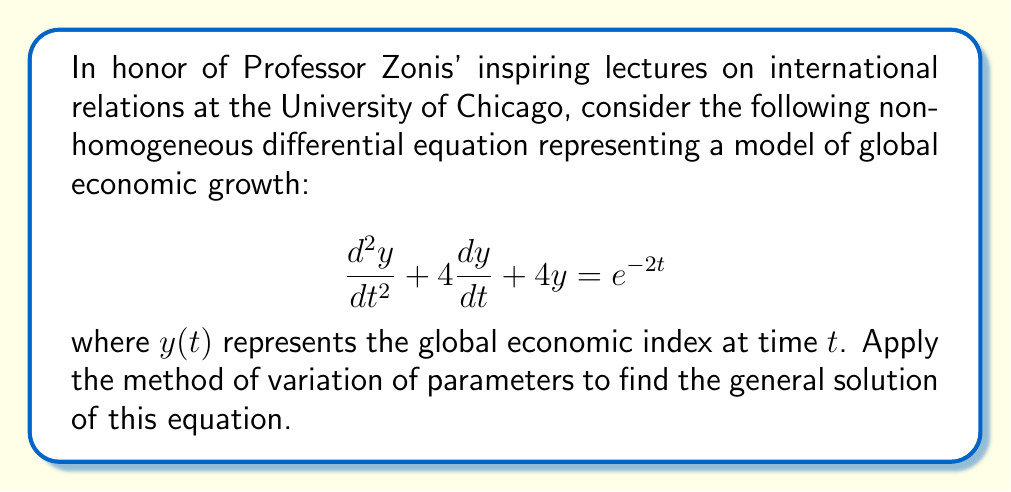Teach me how to tackle this problem. Let's solve this step-by-step using the method of variation of parameters:

1) First, we need to solve the homogeneous equation:
   $$\frac{d^2y}{dt^2} + 4\frac{dy}{dt} + 4y = 0$$

   The characteristic equation is $r^2 + 4r + 4 = 0$
   $(r + 2)^2 = 0$, so $r = -2$ (double root)

   The homogeneous solution is:
   $$y_h = c_1e^{-2t} + c_2te^{-2t}$$

2) Now, we use the method of variation of parameters. Let:
   $$y_p = u_1y_1 + u_2y_2$$
   where $y_1 = e^{-2t}$ and $y_2 = te^{-2t}$

3) We need to solve the system:
   $$\begin{cases}
   u_1'y_1 + u_2'y_2 = 0 \\
   u_1'y_1' + u_2'y_2' = e^{-2t}
   \end{cases}$$

4) Substituting the values:
   $$\begin{cases}
   u_1'e^{-2t} + u_2'te^{-2t} = 0 \\
   u_1'(-2e^{-2t}) + u_2'(e^{-2t} - 2te^{-2t}) = e^{-2t}
   \end{cases}$$

5) Solving this system:
   $$u_1' = \frac{-te^{-2t}}{W} = -\frac{t}{2}$$
   $$u_2' = \frac{e^{-2t}}{W} = \frac{1}{2}$$
   where $W = e^{-4t}$ is the Wronskian

6) Integrating:
   $$u_1 = -\frac{t^2}{4} + C_1$$
   $$u_2 = \frac{t}{2} + C_2$$

7) The particular solution is:
   $$y_p = (-\frac{t^2}{4}e^{-2t}) + (\frac{t}{2}te^{-2t}) = -\frac{t^2}{4}e^{-2t}$$

8) The general solution is the sum of the homogeneous and particular solutions:
   $$y = y_h + y_p = c_1e^{-2t} + c_2te^{-2t} - \frac{t^2}{4}e^{-2t}$$
Answer: The general solution is:
$$y = c_1e^{-2t} + c_2te^{-2t} - \frac{t^2}{4}e^{-2t}$$
where $c_1$ and $c_2$ are arbitrary constants. 